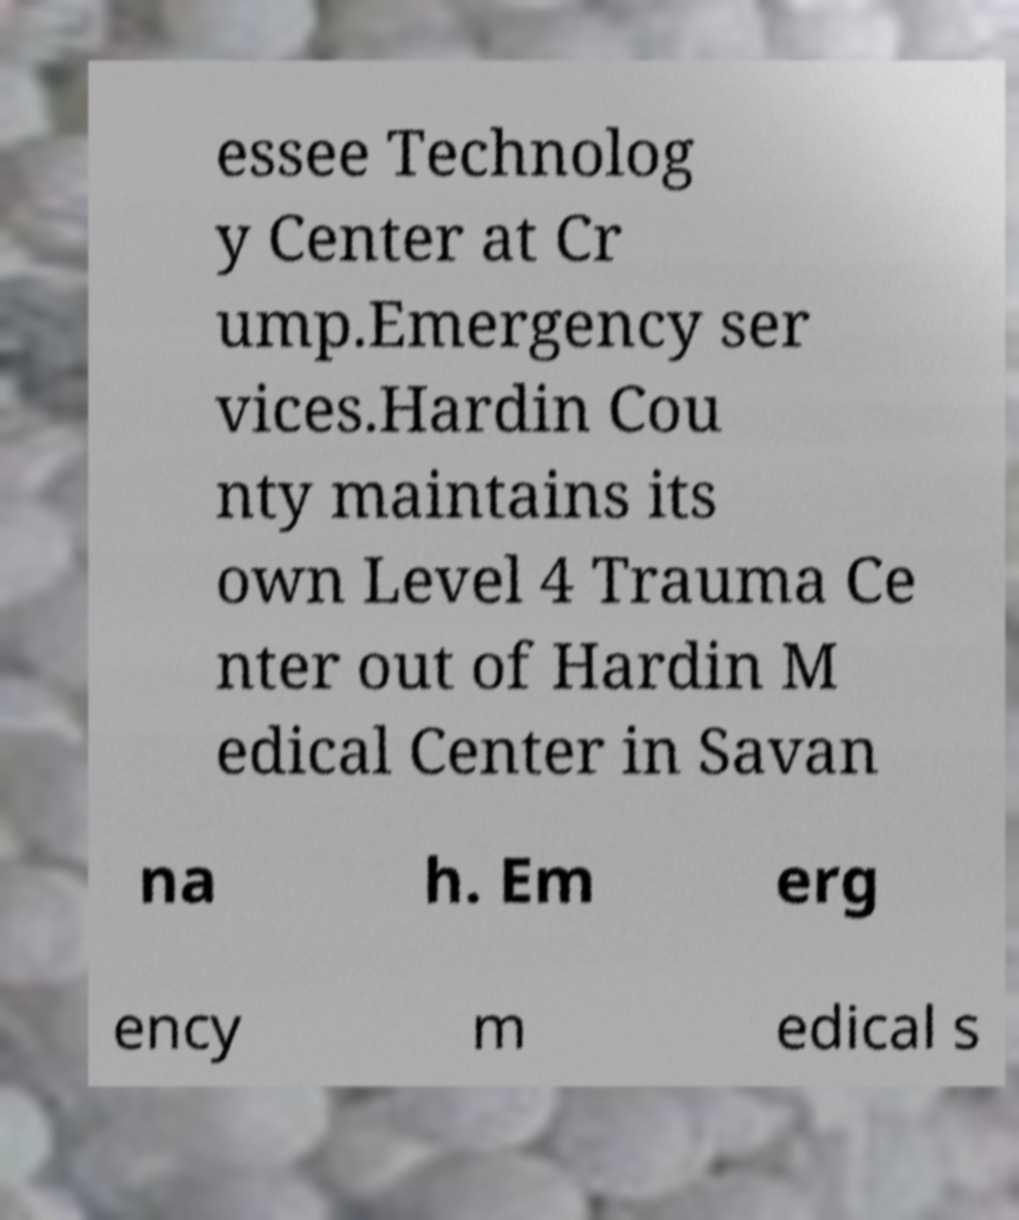Can you read and provide the text displayed in the image?This photo seems to have some interesting text. Can you extract and type it out for me? essee Technolog y Center at Cr ump.Emergency ser vices.Hardin Cou nty maintains its own Level 4 Trauma Ce nter out of Hardin M edical Center in Savan na h. Em erg ency m edical s 